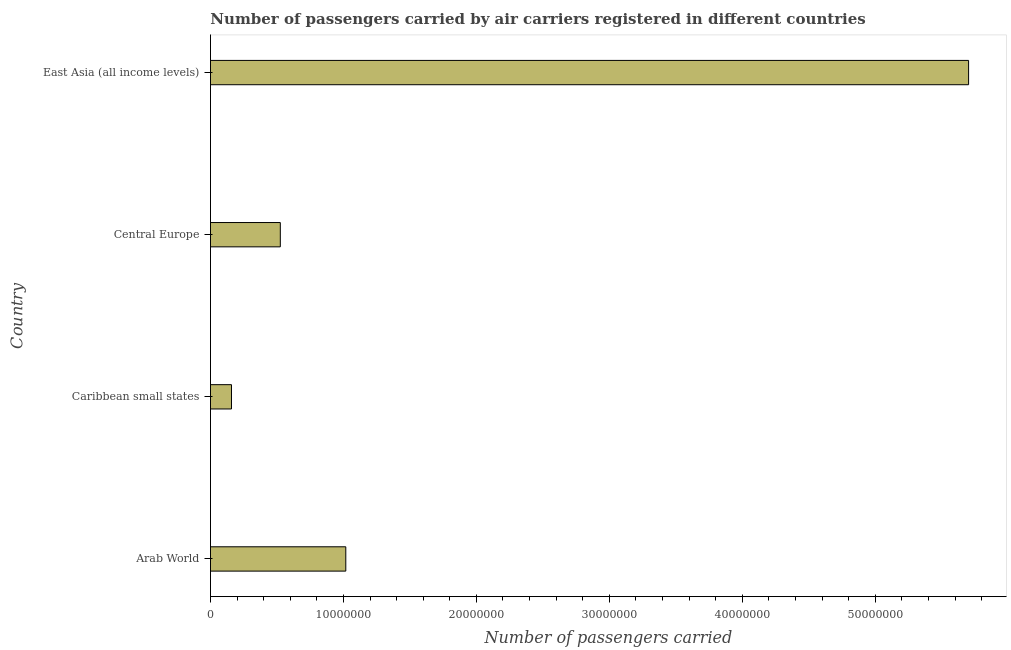Does the graph contain any zero values?
Give a very brief answer. No. What is the title of the graph?
Provide a short and direct response. Number of passengers carried by air carriers registered in different countries. What is the label or title of the X-axis?
Your response must be concise. Number of passengers carried. What is the label or title of the Y-axis?
Your answer should be compact. Country. What is the number of passengers carried in Arab World?
Ensure brevity in your answer.  1.02e+07. Across all countries, what is the maximum number of passengers carried?
Provide a succinct answer. 5.70e+07. Across all countries, what is the minimum number of passengers carried?
Offer a very short reply. 1.58e+06. In which country was the number of passengers carried maximum?
Make the answer very short. East Asia (all income levels). In which country was the number of passengers carried minimum?
Provide a short and direct response. Caribbean small states. What is the sum of the number of passengers carried?
Give a very brief answer. 7.40e+07. What is the difference between the number of passengers carried in Caribbean small states and Central Europe?
Provide a short and direct response. -3.67e+06. What is the average number of passengers carried per country?
Keep it short and to the point. 1.85e+07. What is the median number of passengers carried?
Your response must be concise. 7.72e+06. In how many countries, is the number of passengers carried greater than 16000000 ?
Give a very brief answer. 1. What is the ratio of the number of passengers carried in Caribbean small states to that in East Asia (all income levels)?
Your answer should be very brief. 0.03. Is the number of passengers carried in Arab World less than that in East Asia (all income levels)?
Offer a terse response. Yes. Is the difference between the number of passengers carried in Arab World and East Asia (all income levels) greater than the difference between any two countries?
Your response must be concise. No. What is the difference between the highest and the second highest number of passengers carried?
Provide a succinct answer. 4.68e+07. What is the difference between the highest and the lowest number of passengers carried?
Give a very brief answer. 5.54e+07. How many bars are there?
Keep it short and to the point. 4. Are all the bars in the graph horizontal?
Offer a very short reply. Yes. What is the difference between two consecutive major ticks on the X-axis?
Offer a very short reply. 1.00e+07. Are the values on the major ticks of X-axis written in scientific E-notation?
Offer a terse response. No. What is the Number of passengers carried in Arab World?
Your response must be concise. 1.02e+07. What is the Number of passengers carried of Caribbean small states?
Ensure brevity in your answer.  1.58e+06. What is the Number of passengers carried in Central Europe?
Your response must be concise. 5.25e+06. What is the Number of passengers carried in East Asia (all income levels)?
Give a very brief answer. 5.70e+07. What is the difference between the Number of passengers carried in Arab World and Caribbean small states?
Your answer should be very brief. 8.60e+06. What is the difference between the Number of passengers carried in Arab World and Central Europe?
Make the answer very short. 4.93e+06. What is the difference between the Number of passengers carried in Arab World and East Asia (all income levels)?
Ensure brevity in your answer.  -4.68e+07. What is the difference between the Number of passengers carried in Caribbean small states and Central Europe?
Provide a succinct answer. -3.67e+06. What is the difference between the Number of passengers carried in Caribbean small states and East Asia (all income levels)?
Your answer should be very brief. -5.54e+07. What is the difference between the Number of passengers carried in Central Europe and East Asia (all income levels)?
Provide a succinct answer. -5.18e+07. What is the ratio of the Number of passengers carried in Arab World to that in Caribbean small states?
Ensure brevity in your answer.  6.44. What is the ratio of the Number of passengers carried in Arab World to that in Central Europe?
Give a very brief answer. 1.94. What is the ratio of the Number of passengers carried in Arab World to that in East Asia (all income levels)?
Your response must be concise. 0.18. What is the ratio of the Number of passengers carried in Caribbean small states to that in Central Europe?
Keep it short and to the point. 0.3. What is the ratio of the Number of passengers carried in Caribbean small states to that in East Asia (all income levels)?
Your response must be concise. 0.03. What is the ratio of the Number of passengers carried in Central Europe to that in East Asia (all income levels)?
Offer a very short reply. 0.09. 